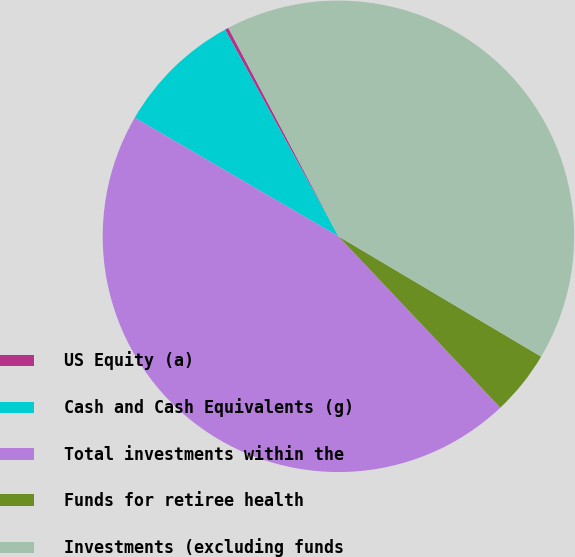Convert chart. <chart><loc_0><loc_0><loc_500><loc_500><pie_chart><fcel>US Equity (a)<fcel>Cash and Cash Equivalents (g)<fcel>Total investments within the<fcel>Funds for retiree health<fcel>Investments (excluding funds<nl><fcel>0.25%<fcel>8.62%<fcel>45.44%<fcel>4.43%<fcel>41.26%<nl></chart> 